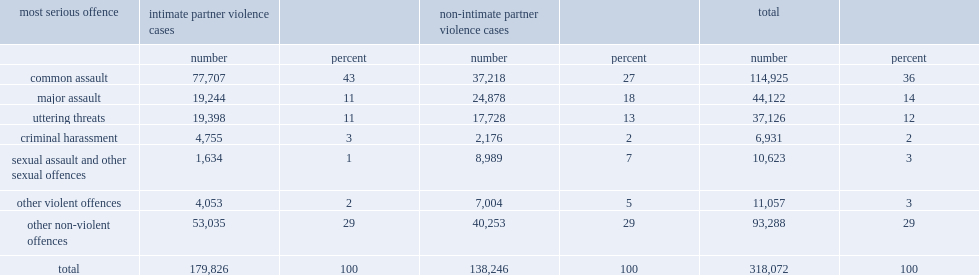How many percentage points were cases involving a non-violent offence? 29.0. How many percentage points have ipv cases been related to common assault? 43.0. How many percentage points have non-ipv cases been related to common assault? 27.0. How many percentage points did non-ipv cases involve major assault? 18.0. How many percentage points did ipv cases involve major assault? 11.0. 